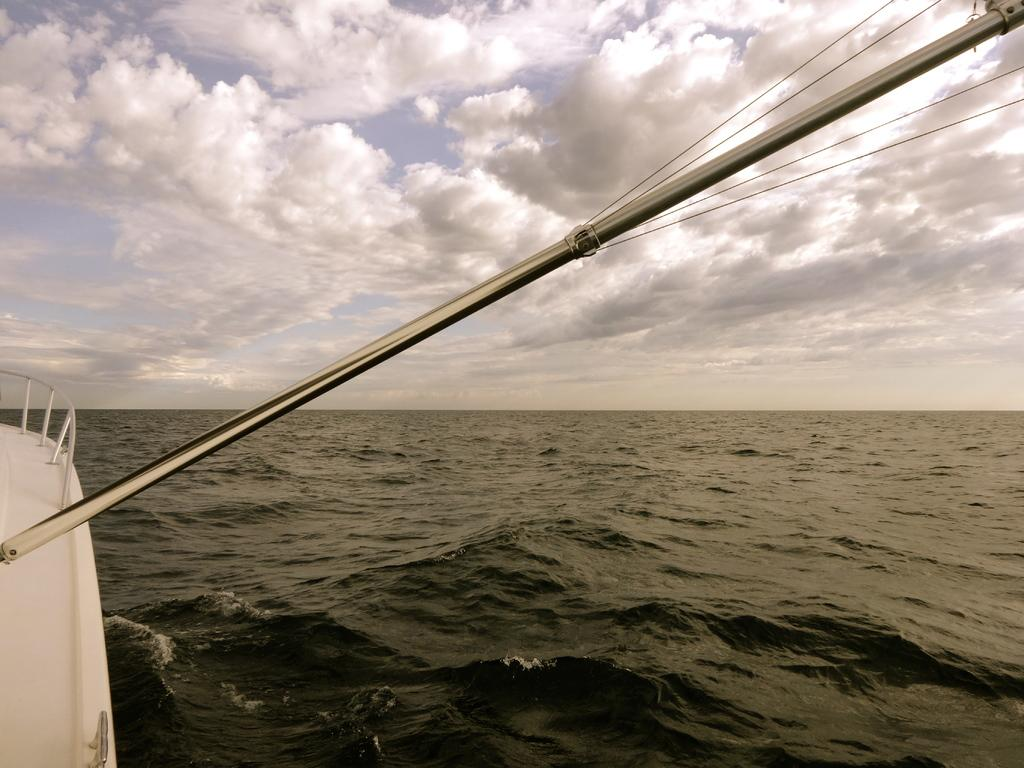What is the main subject of the image? The main subject of the image is a boat. Where is the boat located? The boat is in the water. How would you describe the sky in the image? The sky is blue and cloudy in the image. What type of bread is being used as a guide for the boat in the image? There is no bread present in the image, and bread is not used as a guide for the boat. 